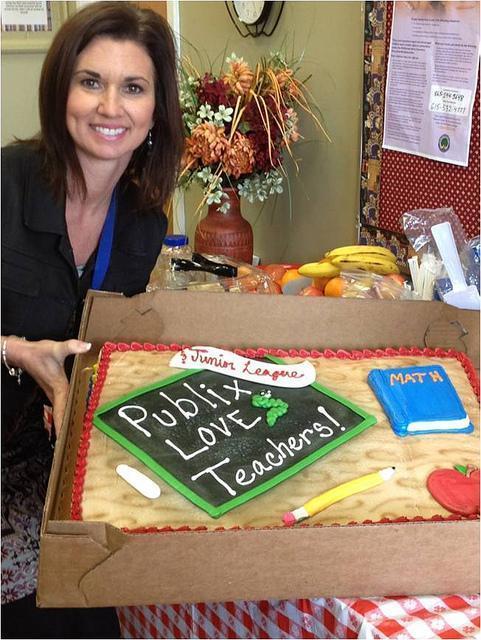How many apples can you see?
Give a very brief answer. 1. How many bikes are shown?
Give a very brief answer. 0. 